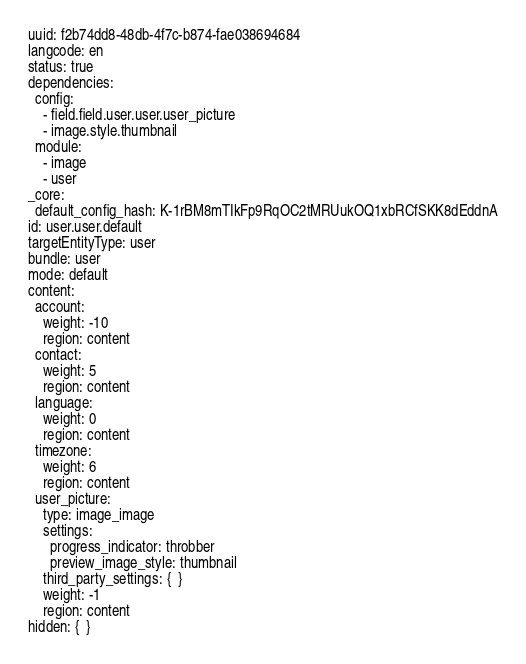Convert code to text. <code><loc_0><loc_0><loc_500><loc_500><_YAML_>uuid: f2b74dd8-48db-4f7c-b874-fae038694684
langcode: en
status: true
dependencies:
  config:
    - field.field.user.user.user_picture
    - image.style.thumbnail
  module:
    - image
    - user
_core:
  default_config_hash: K-1rBM8mTIkFp9RqOC2tMRUukOQ1xbRCfSKK8dEddnA
id: user.user.default
targetEntityType: user
bundle: user
mode: default
content:
  account:
    weight: -10
    region: content
  contact:
    weight: 5
    region: content
  language:
    weight: 0
    region: content
  timezone:
    weight: 6
    region: content
  user_picture:
    type: image_image
    settings:
      progress_indicator: throbber
      preview_image_style: thumbnail
    third_party_settings: {  }
    weight: -1
    region: content
hidden: {  }
</code> 